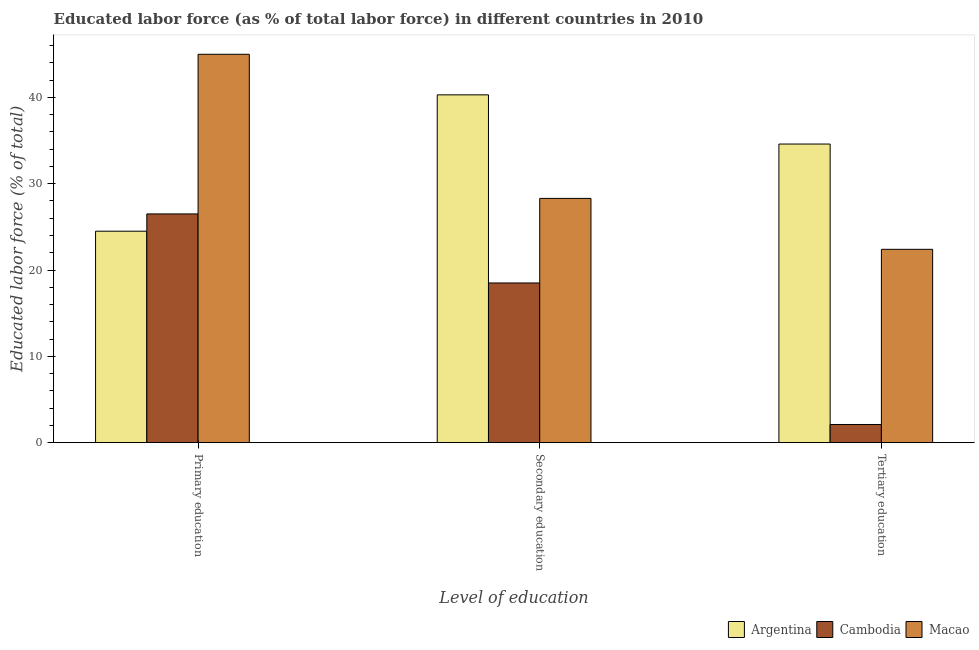How many different coloured bars are there?
Your answer should be very brief. 3. Are the number of bars per tick equal to the number of legend labels?
Keep it short and to the point. Yes. Are the number of bars on each tick of the X-axis equal?
Offer a terse response. Yes. How many bars are there on the 3rd tick from the left?
Make the answer very short. 3. What is the label of the 1st group of bars from the left?
Ensure brevity in your answer.  Primary education. What is the percentage of labor force who received secondary education in Macao?
Ensure brevity in your answer.  28.3. Across all countries, what is the minimum percentage of labor force who received primary education?
Offer a very short reply. 24.5. In which country was the percentage of labor force who received tertiary education minimum?
Make the answer very short. Cambodia. What is the total percentage of labor force who received tertiary education in the graph?
Give a very brief answer. 59.1. What is the difference between the percentage of labor force who received tertiary education in Macao and that in Argentina?
Keep it short and to the point. -12.2. What is the difference between the percentage of labor force who received tertiary education in Argentina and the percentage of labor force who received primary education in Macao?
Make the answer very short. -10.4. In how many countries, is the percentage of labor force who received primary education greater than 14 %?
Your answer should be compact. 3. What is the ratio of the percentage of labor force who received secondary education in Argentina to that in Macao?
Give a very brief answer. 1.42. Is the difference between the percentage of labor force who received secondary education in Cambodia and Argentina greater than the difference between the percentage of labor force who received primary education in Cambodia and Argentina?
Ensure brevity in your answer.  No. What is the difference between the highest and the second highest percentage of labor force who received primary education?
Your response must be concise. 18.5. What is the difference between the highest and the lowest percentage of labor force who received tertiary education?
Your response must be concise. 32.5. In how many countries, is the percentage of labor force who received primary education greater than the average percentage of labor force who received primary education taken over all countries?
Keep it short and to the point. 1. Is the sum of the percentage of labor force who received primary education in Cambodia and Macao greater than the maximum percentage of labor force who received secondary education across all countries?
Ensure brevity in your answer.  Yes. What does the 1st bar from the left in Secondary education represents?
Provide a succinct answer. Argentina. What does the 2nd bar from the right in Primary education represents?
Offer a very short reply. Cambodia. How many bars are there?
Provide a succinct answer. 9. How many countries are there in the graph?
Provide a short and direct response. 3. Are the values on the major ticks of Y-axis written in scientific E-notation?
Offer a terse response. No. Does the graph contain any zero values?
Your response must be concise. No. Where does the legend appear in the graph?
Offer a terse response. Bottom right. How many legend labels are there?
Provide a short and direct response. 3. What is the title of the graph?
Keep it short and to the point. Educated labor force (as % of total labor force) in different countries in 2010. Does "Togo" appear as one of the legend labels in the graph?
Offer a very short reply. No. What is the label or title of the X-axis?
Provide a short and direct response. Level of education. What is the label or title of the Y-axis?
Your answer should be very brief. Educated labor force (% of total). What is the Educated labor force (% of total) in Argentina in Secondary education?
Keep it short and to the point. 40.3. What is the Educated labor force (% of total) in Macao in Secondary education?
Ensure brevity in your answer.  28.3. What is the Educated labor force (% of total) of Argentina in Tertiary education?
Provide a short and direct response. 34.6. What is the Educated labor force (% of total) in Cambodia in Tertiary education?
Provide a short and direct response. 2.1. What is the Educated labor force (% of total) of Macao in Tertiary education?
Ensure brevity in your answer.  22.4. Across all Level of education, what is the maximum Educated labor force (% of total) of Argentina?
Your answer should be very brief. 40.3. Across all Level of education, what is the maximum Educated labor force (% of total) of Cambodia?
Ensure brevity in your answer.  26.5. Across all Level of education, what is the minimum Educated labor force (% of total) in Cambodia?
Provide a succinct answer. 2.1. Across all Level of education, what is the minimum Educated labor force (% of total) of Macao?
Offer a terse response. 22.4. What is the total Educated labor force (% of total) in Argentina in the graph?
Your answer should be compact. 99.4. What is the total Educated labor force (% of total) of Cambodia in the graph?
Your answer should be very brief. 47.1. What is the total Educated labor force (% of total) of Macao in the graph?
Provide a short and direct response. 95.7. What is the difference between the Educated labor force (% of total) of Argentina in Primary education and that in Secondary education?
Your response must be concise. -15.8. What is the difference between the Educated labor force (% of total) of Cambodia in Primary education and that in Secondary education?
Keep it short and to the point. 8. What is the difference between the Educated labor force (% of total) in Macao in Primary education and that in Secondary education?
Provide a short and direct response. 16.7. What is the difference between the Educated labor force (% of total) in Argentina in Primary education and that in Tertiary education?
Keep it short and to the point. -10.1. What is the difference between the Educated labor force (% of total) of Cambodia in Primary education and that in Tertiary education?
Your response must be concise. 24.4. What is the difference between the Educated labor force (% of total) in Macao in Primary education and that in Tertiary education?
Offer a very short reply. 22.6. What is the difference between the Educated labor force (% of total) in Argentina in Secondary education and that in Tertiary education?
Make the answer very short. 5.7. What is the difference between the Educated labor force (% of total) of Macao in Secondary education and that in Tertiary education?
Give a very brief answer. 5.9. What is the difference between the Educated labor force (% of total) of Argentina in Primary education and the Educated labor force (% of total) of Cambodia in Secondary education?
Offer a very short reply. 6. What is the difference between the Educated labor force (% of total) in Argentina in Primary education and the Educated labor force (% of total) in Cambodia in Tertiary education?
Your response must be concise. 22.4. What is the difference between the Educated labor force (% of total) in Argentina in Secondary education and the Educated labor force (% of total) in Cambodia in Tertiary education?
Keep it short and to the point. 38.2. What is the difference between the Educated labor force (% of total) in Argentina in Secondary education and the Educated labor force (% of total) in Macao in Tertiary education?
Offer a very short reply. 17.9. What is the difference between the Educated labor force (% of total) of Cambodia in Secondary education and the Educated labor force (% of total) of Macao in Tertiary education?
Give a very brief answer. -3.9. What is the average Educated labor force (% of total) of Argentina per Level of education?
Your answer should be compact. 33.13. What is the average Educated labor force (% of total) in Cambodia per Level of education?
Offer a terse response. 15.7. What is the average Educated labor force (% of total) of Macao per Level of education?
Give a very brief answer. 31.9. What is the difference between the Educated labor force (% of total) of Argentina and Educated labor force (% of total) of Macao in Primary education?
Your answer should be very brief. -20.5. What is the difference between the Educated labor force (% of total) in Cambodia and Educated labor force (% of total) in Macao in Primary education?
Offer a terse response. -18.5. What is the difference between the Educated labor force (% of total) of Argentina and Educated labor force (% of total) of Cambodia in Secondary education?
Offer a very short reply. 21.8. What is the difference between the Educated labor force (% of total) in Cambodia and Educated labor force (% of total) in Macao in Secondary education?
Give a very brief answer. -9.8. What is the difference between the Educated labor force (% of total) in Argentina and Educated labor force (% of total) in Cambodia in Tertiary education?
Your answer should be compact. 32.5. What is the difference between the Educated labor force (% of total) of Argentina and Educated labor force (% of total) of Macao in Tertiary education?
Offer a terse response. 12.2. What is the difference between the Educated labor force (% of total) of Cambodia and Educated labor force (% of total) of Macao in Tertiary education?
Ensure brevity in your answer.  -20.3. What is the ratio of the Educated labor force (% of total) of Argentina in Primary education to that in Secondary education?
Make the answer very short. 0.61. What is the ratio of the Educated labor force (% of total) in Cambodia in Primary education to that in Secondary education?
Your response must be concise. 1.43. What is the ratio of the Educated labor force (% of total) in Macao in Primary education to that in Secondary education?
Your response must be concise. 1.59. What is the ratio of the Educated labor force (% of total) in Argentina in Primary education to that in Tertiary education?
Your answer should be very brief. 0.71. What is the ratio of the Educated labor force (% of total) of Cambodia in Primary education to that in Tertiary education?
Keep it short and to the point. 12.62. What is the ratio of the Educated labor force (% of total) of Macao in Primary education to that in Tertiary education?
Keep it short and to the point. 2.01. What is the ratio of the Educated labor force (% of total) in Argentina in Secondary education to that in Tertiary education?
Offer a very short reply. 1.16. What is the ratio of the Educated labor force (% of total) in Cambodia in Secondary education to that in Tertiary education?
Provide a succinct answer. 8.81. What is the ratio of the Educated labor force (% of total) in Macao in Secondary education to that in Tertiary education?
Offer a terse response. 1.26. What is the difference between the highest and the lowest Educated labor force (% of total) in Argentina?
Give a very brief answer. 15.8. What is the difference between the highest and the lowest Educated labor force (% of total) of Cambodia?
Make the answer very short. 24.4. What is the difference between the highest and the lowest Educated labor force (% of total) in Macao?
Ensure brevity in your answer.  22.6. 